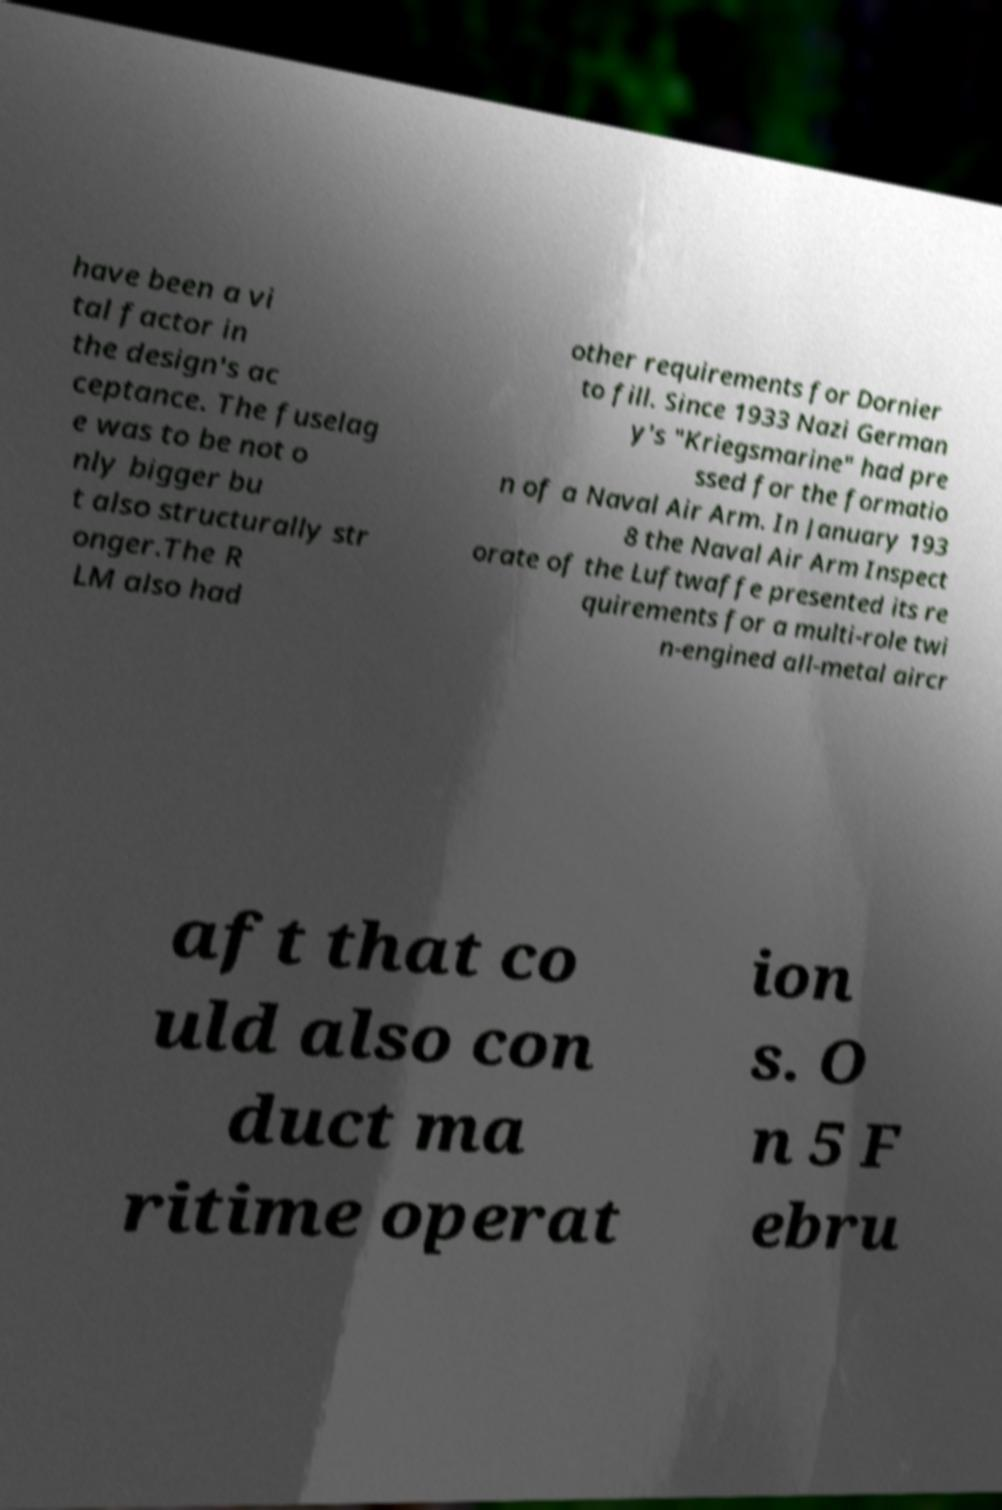There's text embedded in this image that I need extracted. Can you transcribe it verbatim? have been a vi tal factor in the design's ac ceptance. The fuselag e was to be not o nly bigger bu t also structurally str onger.The R LM also had other requirements for Dornier to fill. Since 1933 Nazi German y's "Kriegsmarine" had pre ssed for the formatio n of a Naval Air Arm. In January 193 8 the Naval Air Arm Inspect orate of the Luftwaffe presented its re quirements for a multi-role twi n-engined all-metal aircr aft that co uld also con duct ma ritime operat ion s. O n 5 F ebru 